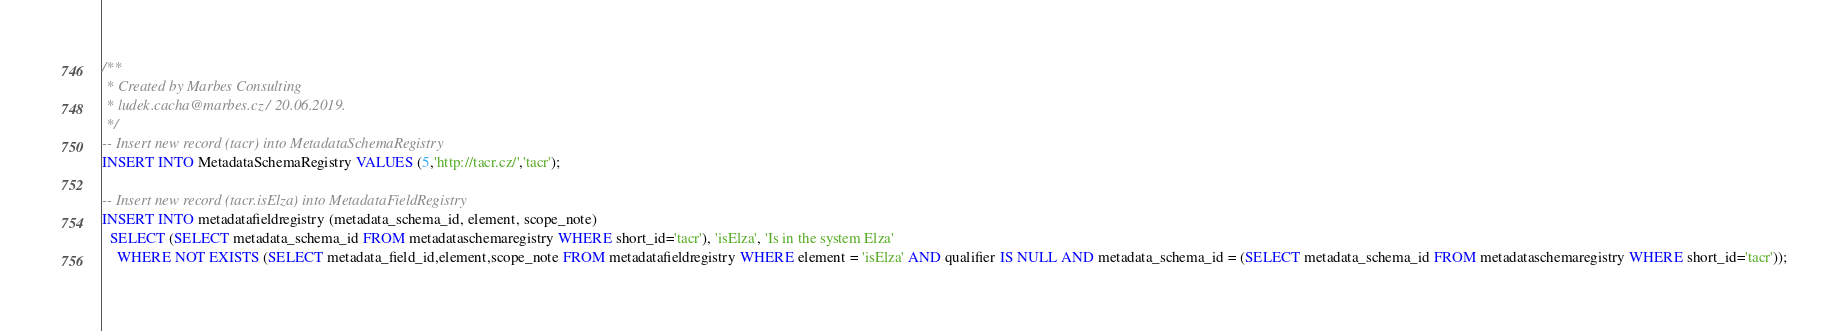Convert code to text. <code><loc_0><loc_0><loc_500><loc_500><_SQL_>/**
 * Created by Marbes Consulting
 * ludek.cacha@marbes.cz / 20.06.2019.
 */
-- Insert new record (tacr) into MetadataSchemaRegistry
INSERT INTO MetadataSchemaRegistry VALUES (5,'http://tacr.cz/','tacr');

-- Insert new record (tacr.isElza) into MetadataFieldRegistry
INSERT INTO metadatafieldregistry (metadata_schema_id, element, scope_note)
  SELECT (SELECT metadata_schema_id FROM metadataschemaregistry WHERE short_id='tacr'), 'isElza', 'Is in the system Elza'
    WHERE NOT EXISTS (SELECT metadata_field_id,element,scope_note FROM metadatafieldregistry WHERE element = 'isElza' AND qualifier IS NULL AND metadata_schema_id = (SELECT metadata_schema_id FROM metadataschemaregistry WHERE short_id='tacr'));
</code> 